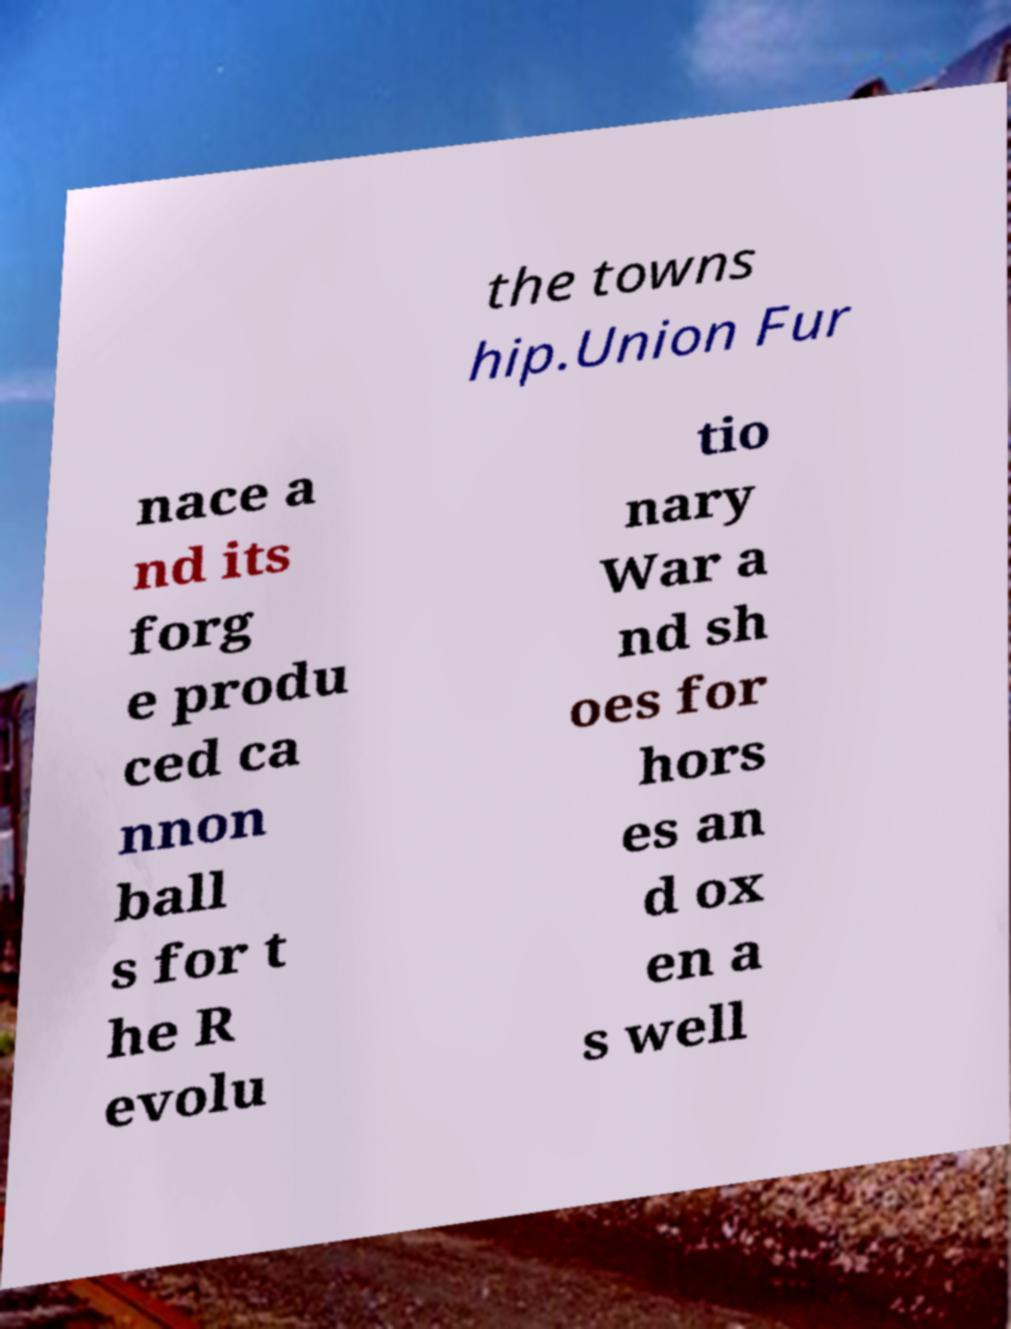Could you assist in decoding the text presented in this image and type it out clearly? the towns hip.Union Fur nace a nd its forg e produ ced ca nnon ball s for t he R evolu tio nary War a nd sh oes for hors es an d ox en a s well 